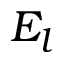Convert formula to latex. <formula><loc_0><loc_0><loc_500><loc_500>E _ { l }</formula> 